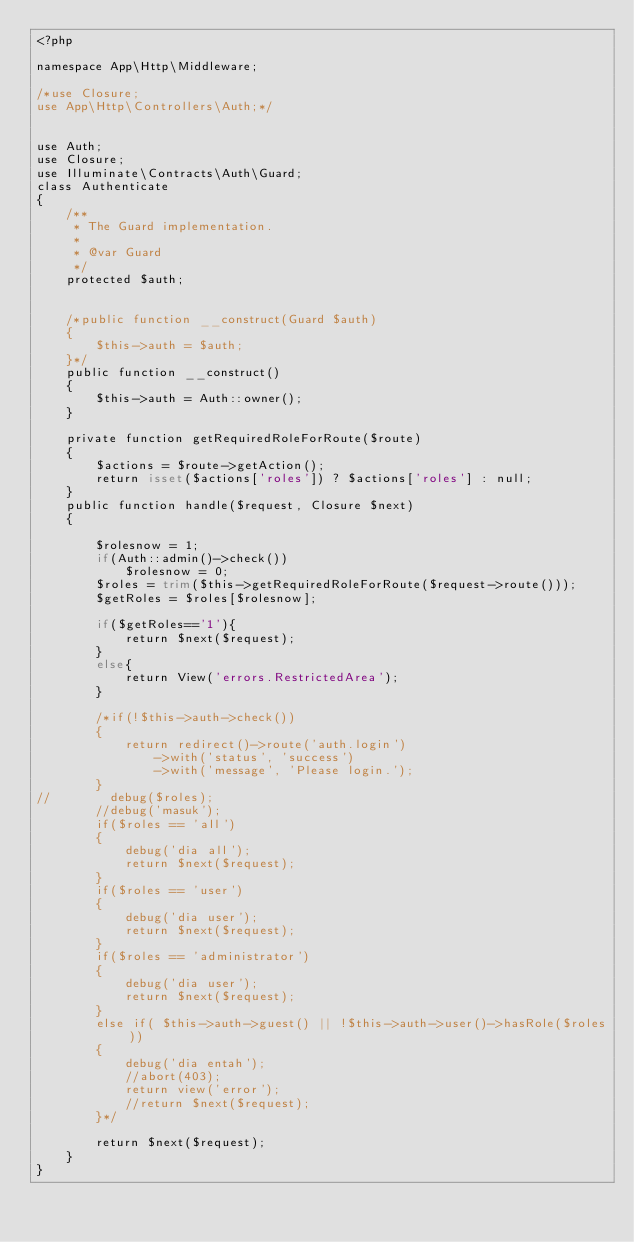<code> <loc_0><loc_0><loc_500><loc_500><_PHP_><?php

namespace App\Http\Middleware;

/*use Closure;
use App\Http\Controllers\Auth;*/


use Auth;
use Closure;
use Illuminate\Contracts\Auth\Guard;
class Authenticate
{
    /**
     * The Guard implementation.
     *
     * @var Guard
     */
    protected $auth;


    /*public function __construct(Guard $auth)
    {
        $this->auth = $auth;
    }*/
    public function __construct()
    {
        $this->auth = Auth::owner();
    }

    private function getRequiredRoleForRoute($route)
    {
        $actions = $route->getAction();
        return isset($actions['roles']) ? $actions['roles'] : null;
    }
    public function handle($request, Closure $next)
    {

        $rolesnow = 1;
        if(Auth::admin()->check())
            $rolesnow = 0;
        $roles = trim($this->getRequiredRoleForRoute($request->route()));
        $getRoles = $roles[$rolesnow];

        if($getRoles=='1'){
            return $next($request);
        }
        else{
            return View('errors.RestrictedArea');
        }

        /*if(!$this->auth->check())
        {
            return redirect()->route('auth.login')
                ->with('status', 'success')
                ->with('message', 'Please login.');
        }
//        debug($roles);
        //debug('masuk');
        if($roles == 'all')
        {
            debug('dia all');
            return $next($request);
        }
        if($roles == 'user')
        {
            debug('dia user');
            return $next($request);
        }
        if($roles == 'administrator')
        {
            debug('dia user');
            return $next($request);
        }
        else if( $this->auth->guest() || !$this->auth->user()->hasRole($roles))
        {
            debug('dia entah');
            //abort(403);
            return view('error');
            //return $next($request);
        }*/

        return $next($request);
    }
}
</code> 